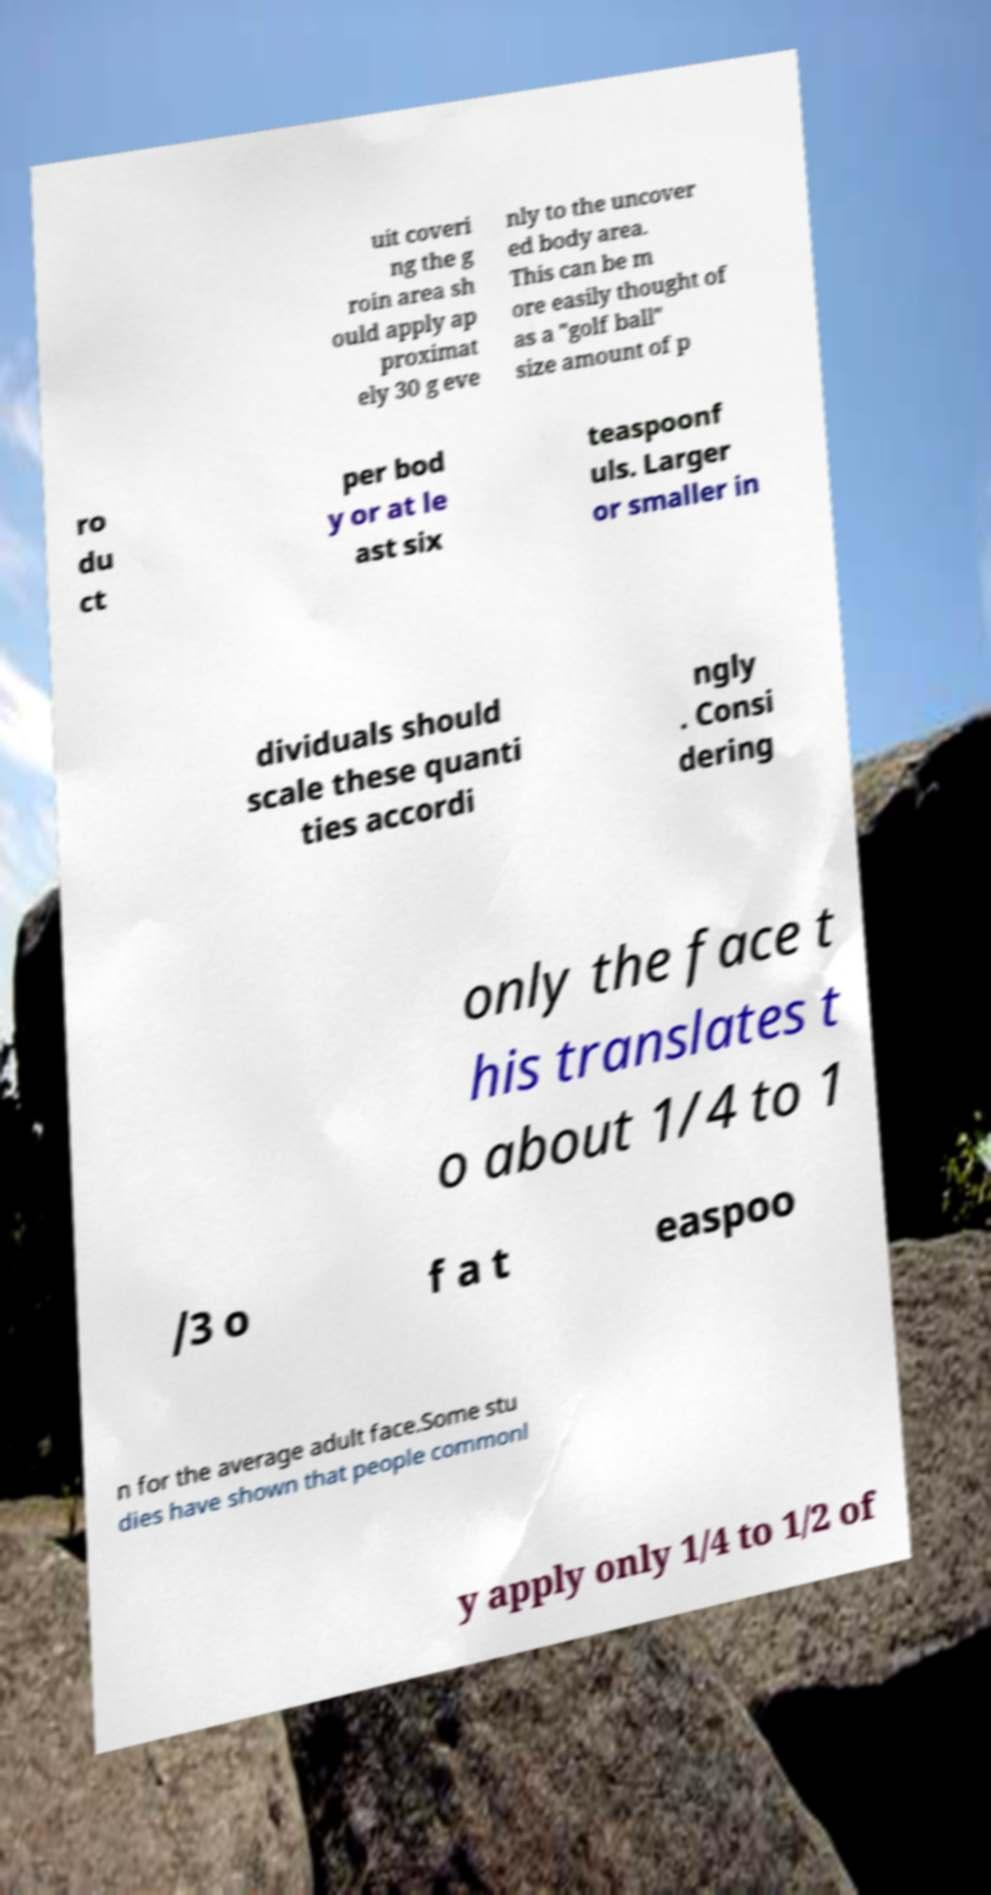There's text embedded in this image that I need extracted. Can you transcribe it verbatim? uit coveri ng the g roin area sh ould apply ap proximat ely 30 g eve nly to the uncover ed body area. This can be m ore easily thought of as a "golf ball" size amount of p ro du ct per bod y or at le ast six teaspoonf uls. Larger or smaller in dividuals should scale these quanti ties accordi ngly . Consi dering only the face t his translates t o about 1/4 to 1 /3 o f a t easpoo n for the average adult face.Some stu dies have shown that people commonl y apply only 1/4 to 1/2 of 